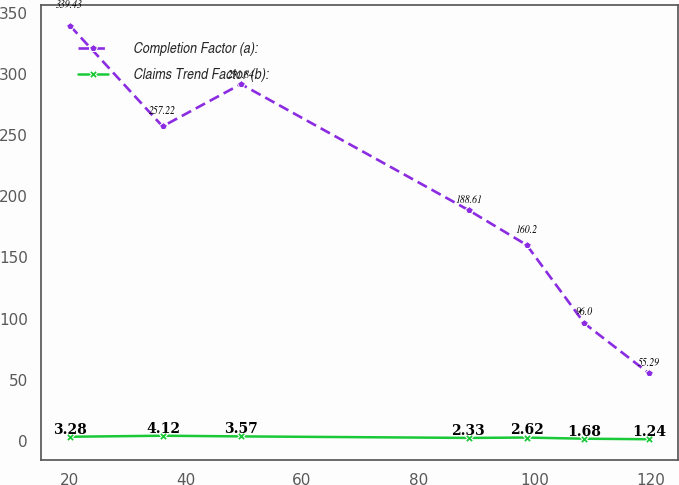Convert chart to OTSL. <chart><loc_0><loc_0><loc_500><loc_500><line_chart><ecel><fcel>Completion Factor (a):<fcel>Claims Trend Factor (b):<nl><fcel>20.08<fcel>339.43<fcel>3.28<nl><fcel>35.99<fcel>257.22<fcel>4.12<nl><fcel>49.48<fcel>291.84<fcel>3.57<nl><fcel>88.71<fcel>188.61<fcel>2.33<nl><fcel>98.67<fcel>160.2<fcel>2.62<nl><fcel>108.63<fcel>96<fcel>1.68<nl><fcel>119.7<fcel>55.29<fcel>1.24<nl></chart> 